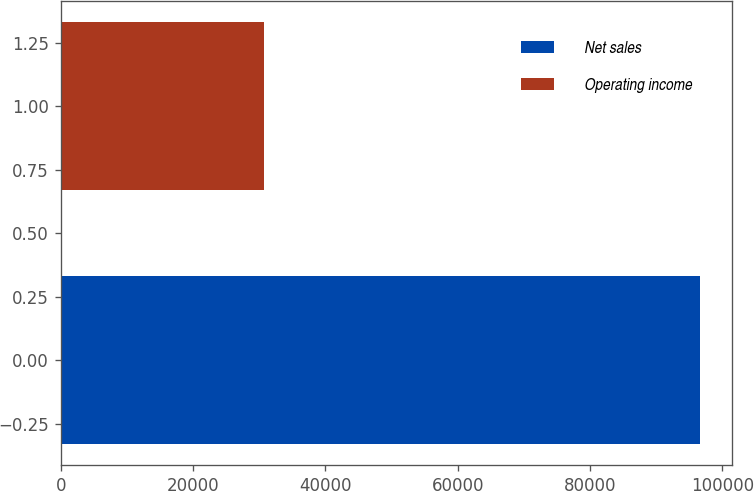Convert chart to OTSL. <chart><loc_0><loc_0><loc_500><loc_500><bar_chart><fcel>Net sales<fcel>Operating income<nl><fcel>96600<fcel>30684<nl></chart> 